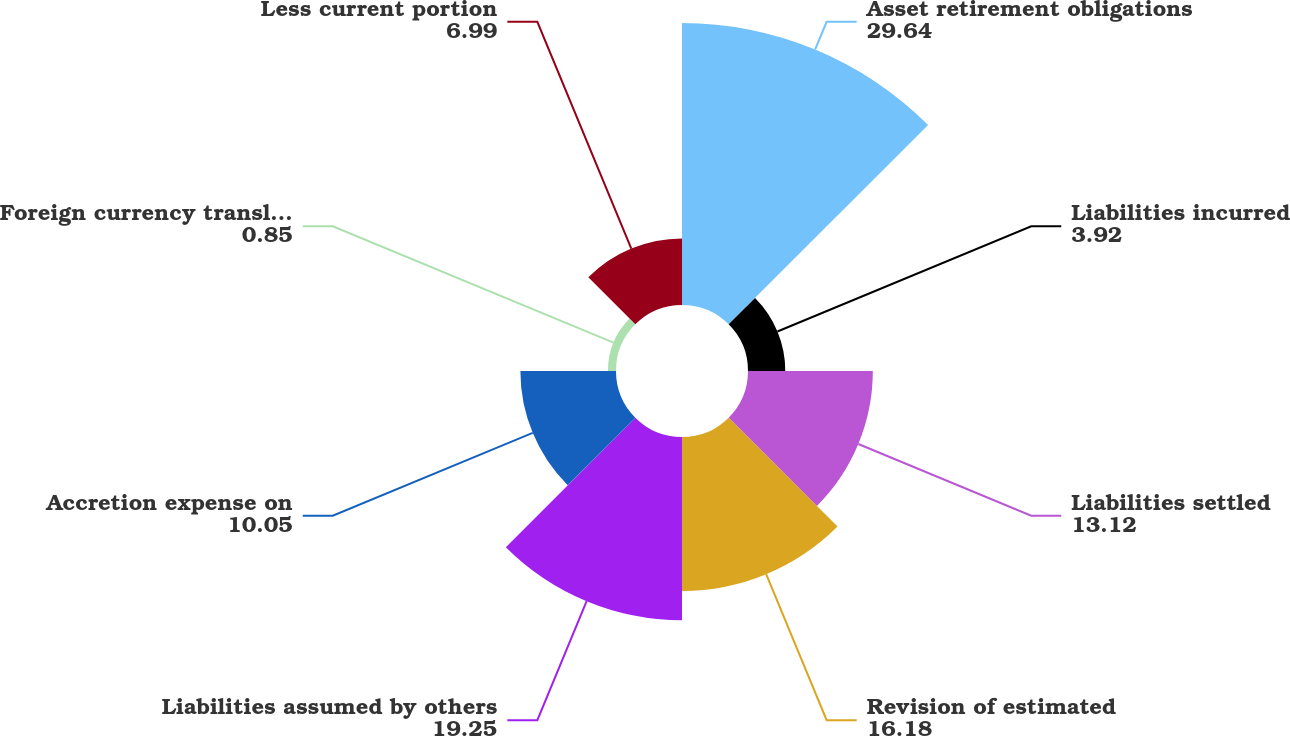Convert chart. <chart><loc_0><loc_0><loc_500><loc_500><pie_chart><fcel>Asset retirement obligations<fcel>Liabilities incurred<fcel>Liabilities settled<fcel>Revision of estimated<fcel>Liabilities assumed by others<fcel>Accretion expense on<fcel>Foreign currency translation<fcel>Less current portion<nl><fcel>29.64%<fcel>3.92%<fcel>13.12%<fcel>16.18%<fcel>19.25%<fcel>10.05%<fcel>0.85%<fcel>6.99%<nl></chart> 